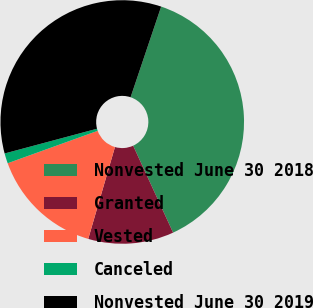<chart> <loc_0><loc_0><loc_500><loc_500><pie_chart><fcel>Nonvested June 30 2018<fcel>Granted<fcel>Vested<fcel>Canceled<fcel>Nonvested June 30 2019<nl><fcel>37.97%<fcel>11.36%<fcel>14.99%<fcel>1.34%<fcel>34.34%<nl></chart> 